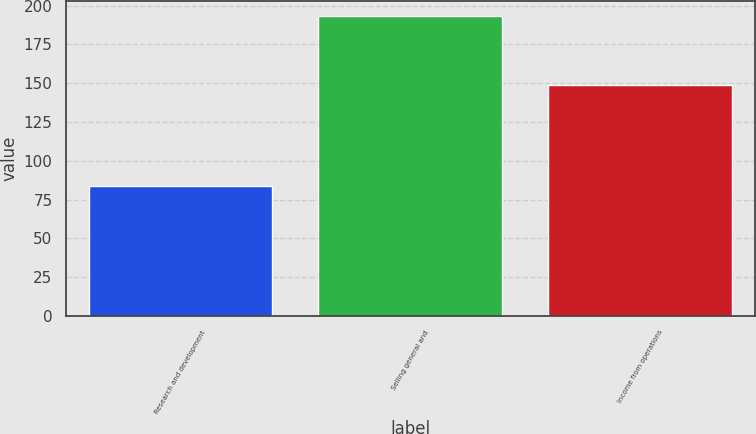<chart> <loc_0><loc_0><loc_500><loc_500><bar_chart><fcel>Research and development<fcel>Selling general and<fcel>Income from operations<nl><fcel>84<fcel>193<fcel>149<nl></chart> 